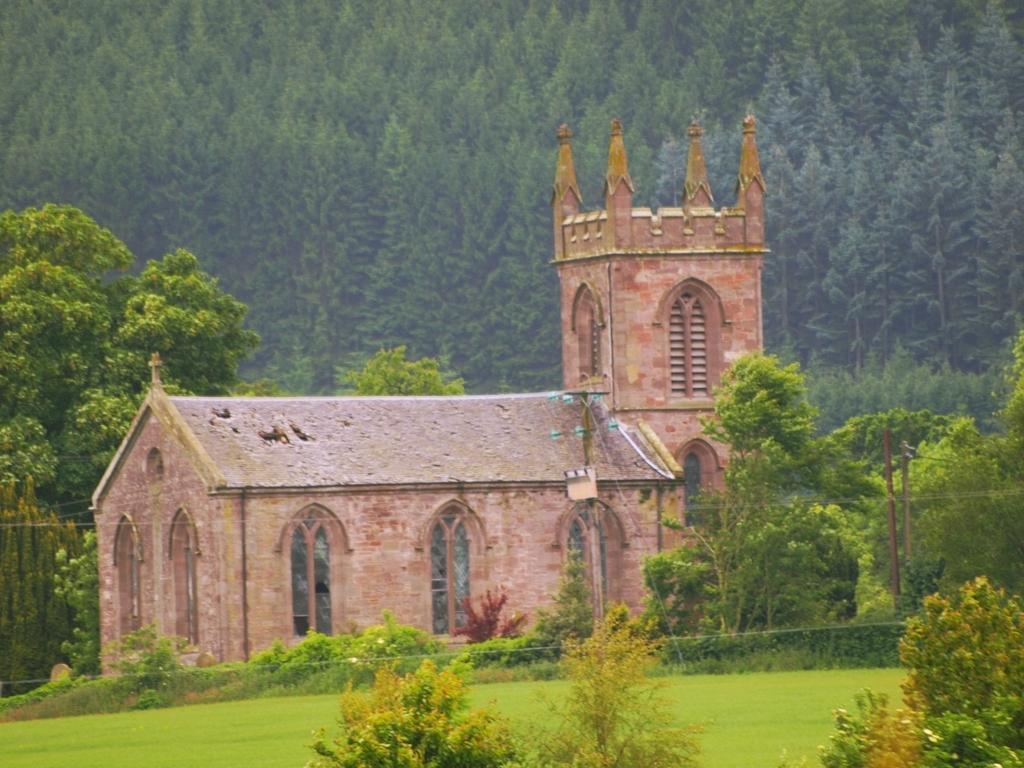In one or two sentences, can you explain what this image depicts? In this image, we can see green grass on the ground, there are some green color plants, we can see a house, in the background there are some green color trees. 